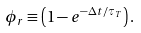Convert formula to latex. <formula><loc_0><loc_0><loc_500><loc_500>\phi _ { r } \equiv \left ( 1 - e ^ { - \Delta t / \tau _ { T } } \right ) .</formula> 